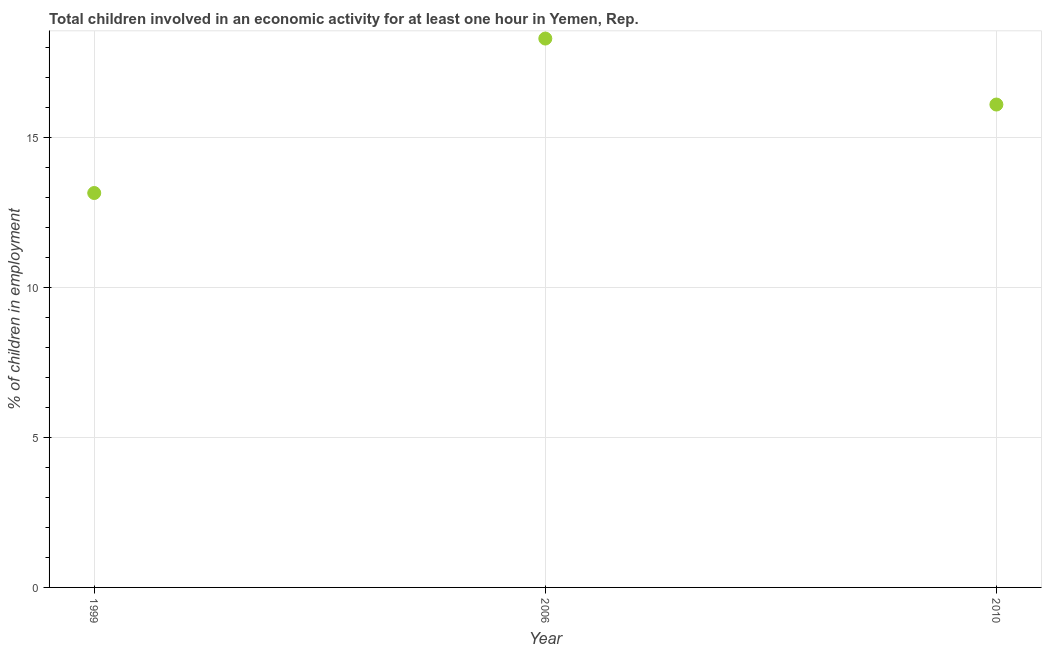Across all years, what is the minimum percentage of children in employment?
Provide a short and direct response. 13.15. In which year was the percentage of children in employment maximum?
Provide a short and direct response. 2006. What is the sum of the percentage of children in employment?
Offer a very short reply. 47.55. What is the difference between the percentage of children in employment in 2006 and 2010?
Ensure brevity in your answer.  2.2. What is the average percentage of children in employment per year?
Ensure brevity in your answer.  15.85. In how many years, is the percentage of children in employment greater than 15 %?
Provide a short and direct response. 2. Do a majority of the years between 2006 and 2010 (inclusive) have percentage of children in employment greater than 1 %?
Your response must be concise. Yes. What is the ratio of the percentage of children in employment in 1999 to that in 2006?
Offer a very short reply. 0.72. Is the percentage of children in employment in 1999 less than that in 2010?
Offer a very short reply. Yes. What is the difference between the highest and the second highest percentage of children in employment?
Provide a succinct answer. 2.2. What is the difference between the highest and the lowest percentage of children in employment?
Keep it short and to the point. 5.15. In how many years, is the percentage of children in employment greater than the average percentage of children in employment taken over all years?
Offer a terse response. 2. Does the percentage of children in employment monotonically increase over the years?
Make the answer very short. No. Are the values on the major ticks of Y-axis written in scientific E-notation?
Provide a short and direct response. No. Does the graph contain any zero values?
Make the answer very short. No. Does the graph contain grids?
Your answer should be very brief. Yes. What is the title of the graph?
Offer a very short reply. Total children involved in an economic activity for at least one hour in Yemen, Rep. What is the label or title of the Y-axis?
Offer a very short reply. % of children in employment. What is the % of children in employment in 1999?
Make the answer very short. 13.15. What is the % of children in employment in 2006?
Keep it short and to the point. 18.3. What is the difference between the % of children in employment in 1999 and 2006?
Ensure brevity in your answer.  -5.15. What is the difference between the % of children in employment in 1999 and 2010?
Give a very brief answer. -2.95. What is the difference between the % of children in employment in 2006 and 2010?
Your response must be concise. 2.2. What is the ratio of the % of children in employment in 1999 to that in 2006?
Your answer should be compact. 0.72. What is the ratio of the % of children in employment in 1999 to that in 2010?
Offer a very short reply. 0.82. What is the ratio of the % of children in employment in 2006 to that in 2010?
Ensure brevity in your answer.  1.14. 